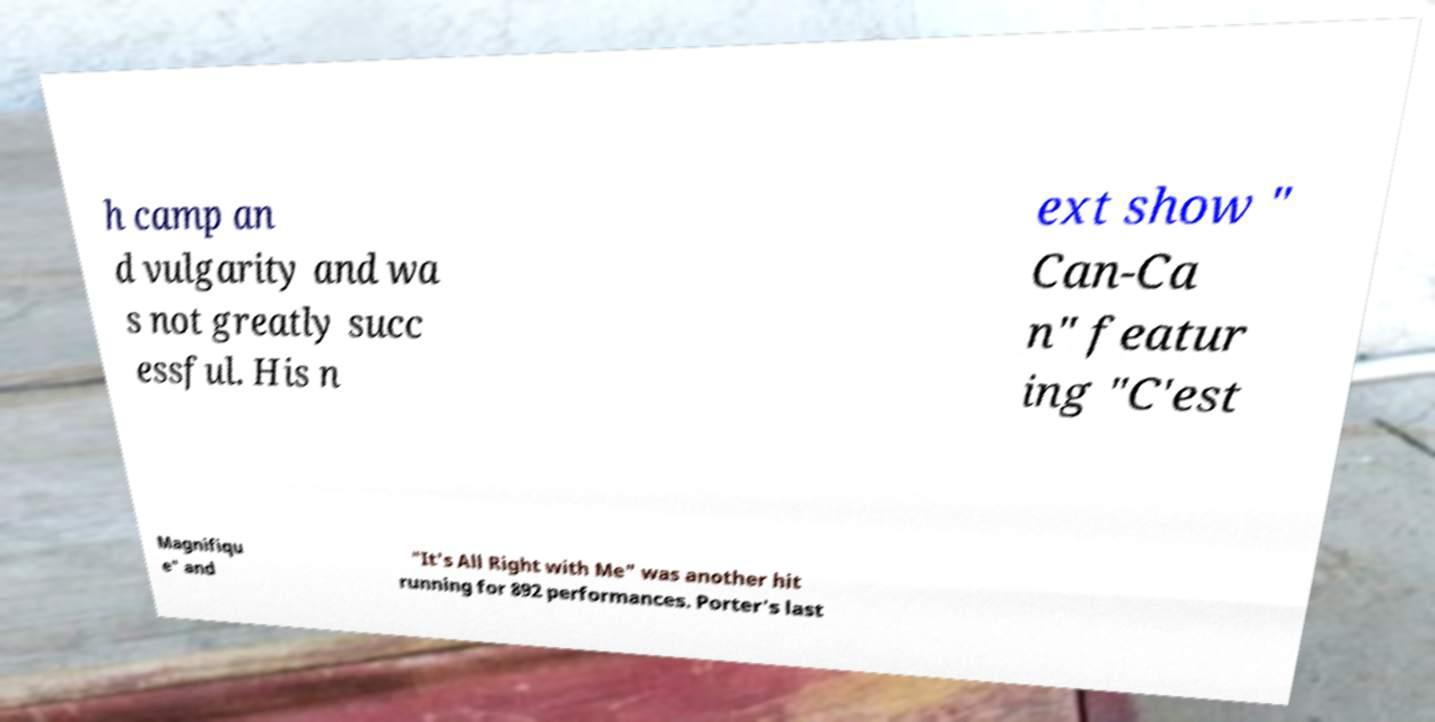For documentation purposes, I need the text within this image transcribed. Could you provide that? h camp an d vulgarity and wa s not greatly succ essful. His n ext show " Can-Ca n" featur ing "C'est Magnifiqu e" and "It's All Right with Me" was another hit running for 892 performances. Porter's last 